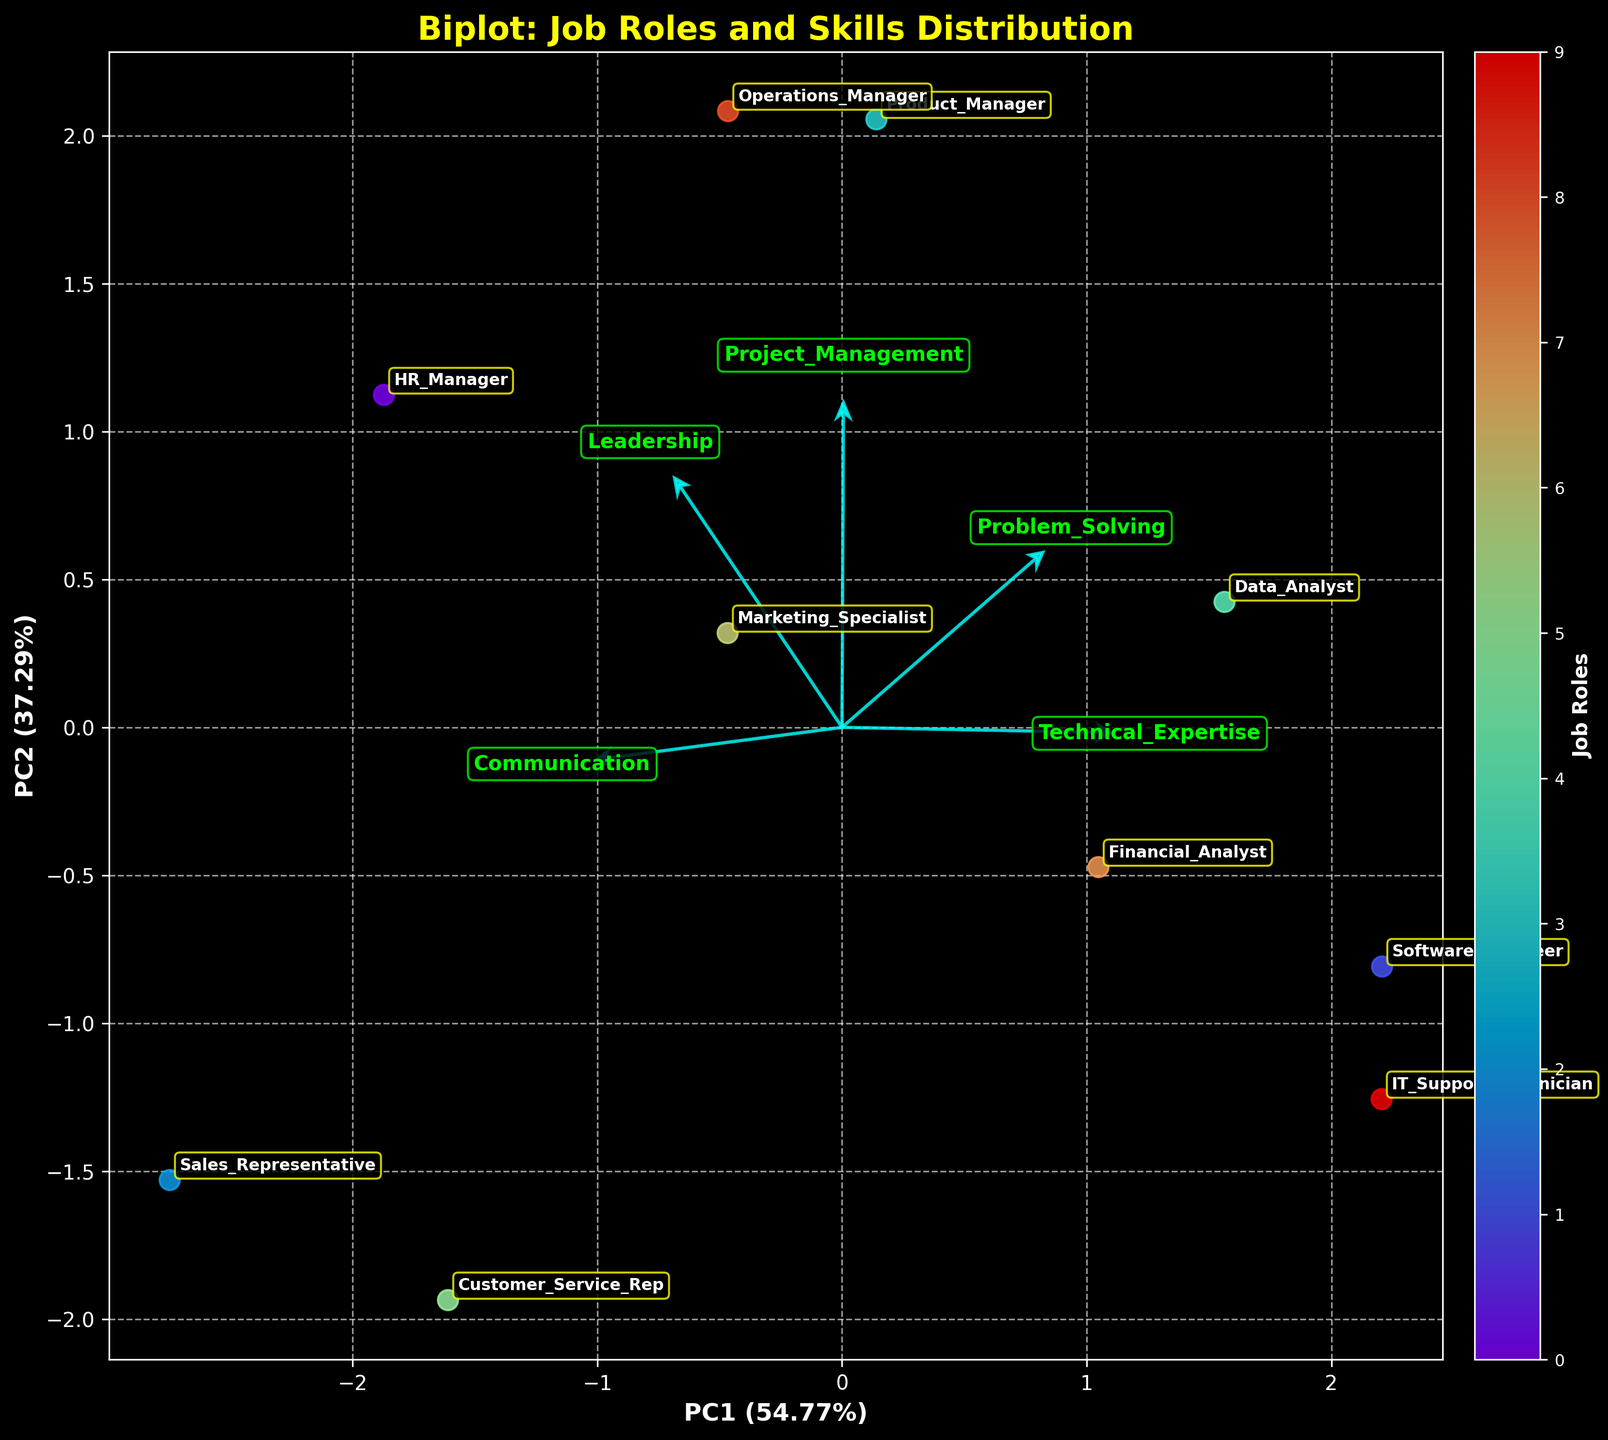What is the title of the biplot? The title is usually displayed at the top of the figure. It provides a brief description of the plot.
Answer: Biplot: Job Roles and Skills Distribution How many job roles are represented in the plot? Count the number of unique labels annotated in the plot. Each label represents a job role.
Answer: 10 Which job role appears to have the highest coordination between Communication and Leadership skills? Look for job roles close to the directions of both the Communication and Leadership loading vectors.
Answer: HR_Manager Which skill is most closely associated with the Product Manager job role? Locate the Product Manager's position on the plot and observe which loading vector is the nearest or most aligned with it.
Answer: Project_Management Between Software Engineer and IT Support Technician, which role scores higher in Technical Expertise based on the plot? Identify the positions of Software Engineer and IT Support Technician and observe their proximity to the Technical Expertise loading vector.
Answer: Both score high, but IT_Support_Technician is slightly higher Which two job roles have the highest scores in Problem Solving skill? Look for the job roles nearest to the Problem Solving loading vector.
Answer: Product_Manager, Data_Analyst Is there any skill that appears to be negatively correlated with the Communication skill? Notice loading vectors pointing in opposite directions to identify negative correlations.
Answer: No clear negative correlation is shown Which skill vector contributes the most to the second principal component (PC2)? Find the skill vector with the largest projection on the PC2 axis.
Answer: Problem_Solving How are Customer Service Rep and Sales Representative positioned relative to each other in terms of Communication and Problem Solving skills? Compare the positions of Customer Service Rep and Sales Representative with respect to the Communication and Problem Solving vectors.
Answer: Both are high in Communication, but Customer Service Rep is slightly better in Problem Solving 